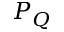Convert formula to latex. <formula><loc_0><loc_0><loc_500><loc_500>P _ { Q }</formula> 